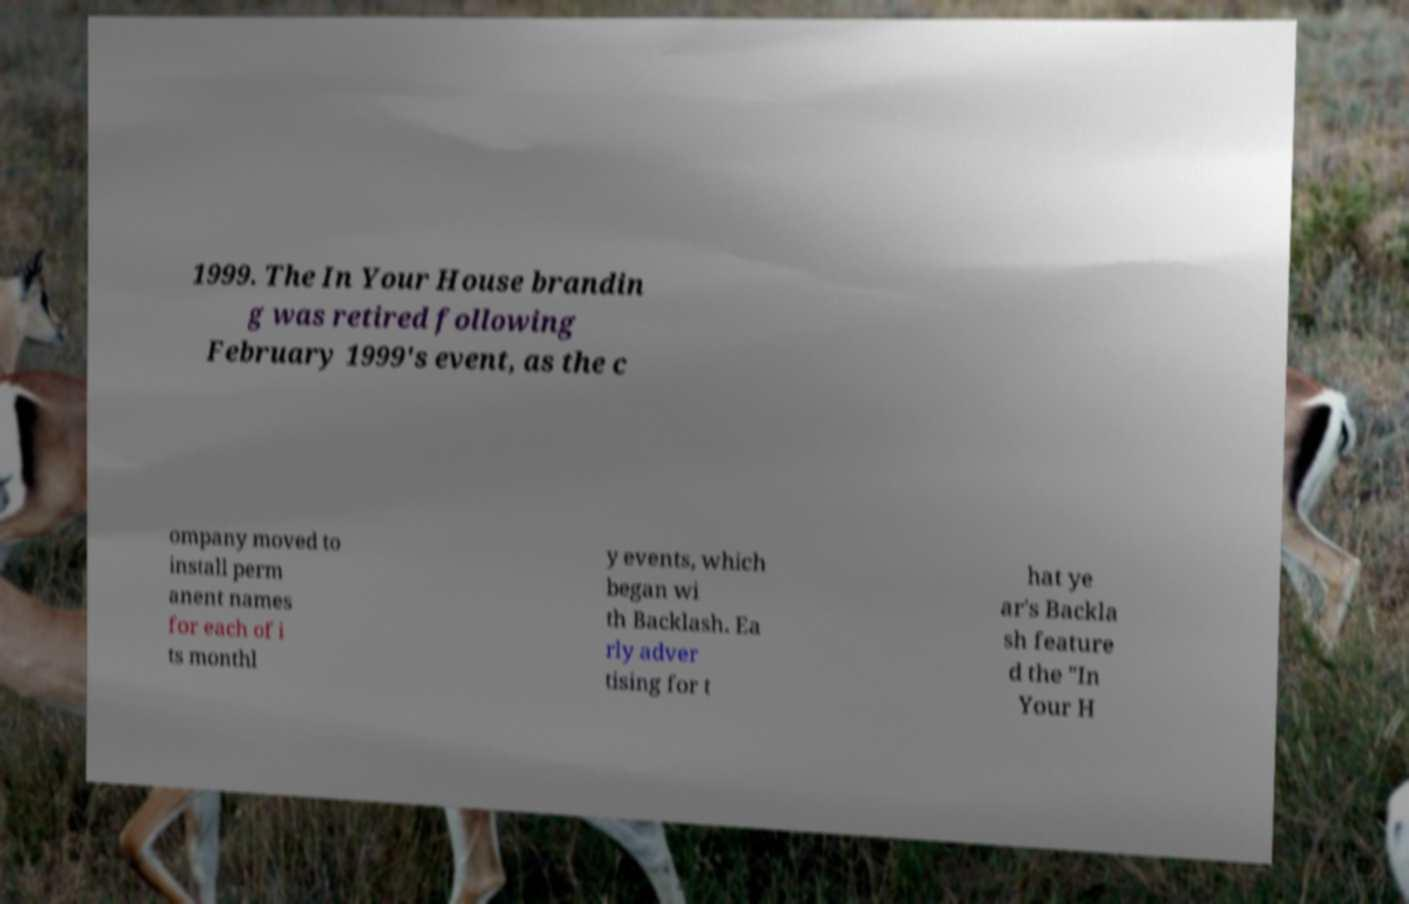Can you read and provide the text displayed in the image?This photo seems to have some interesting text. Can you extract and type it out for me? 1999. The In Your House brandin g was retired following February 1999's event, as the c ompany moved to install perm anent names for each of i ts monthl y events, which began wi th Backlash. Ea rly adver tising for t hat ye ar's Backla sh feature d the "In Your H 